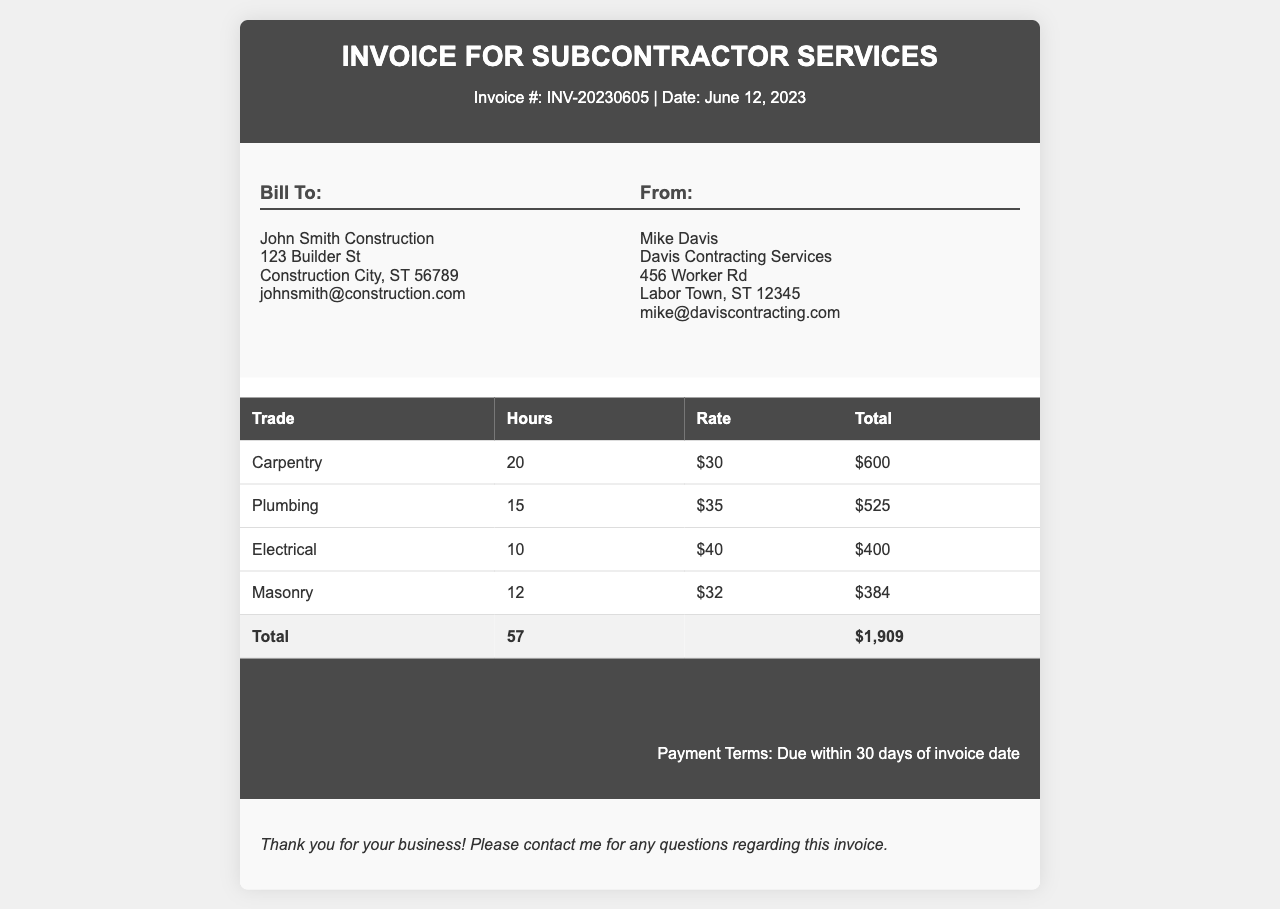what is the invoice number? The invoice number is indicated in the document, following the "Invoice #:" label.
Answer: INV-20230605 who is the billing recipient? The billing recipient is the company to which the invoice is addressed, found in the "Bill To:" section.
Answer: John Smith Construction how many hours were spent on Plumbing? The document lists the hours worked for each trade, specifically under the Plumbing row.
Answer: 15 what is the total amount due? The total amount due is presented in the invoice summary section as "Total Due:".
Answer: $1,909 what is the labor rate for Electrical work? The labor rate for Electrical work is shown in the corresponding row, under the "Rate" column.
Answer: $40 which trade has the highest total? To find this, compare the total amounts calculated for each trade listed in the invoice table.
Answer: Carpentry how many different trades are listed in the invoice? The number of trades is determined by counting the entries in the table's trade column.
Answer: 4 what is the payment term mentioned in the invoice? The payment term is stated in the invoice summary section, indicating when payment is expected.
Answer: Due within 30 days of invoice date 